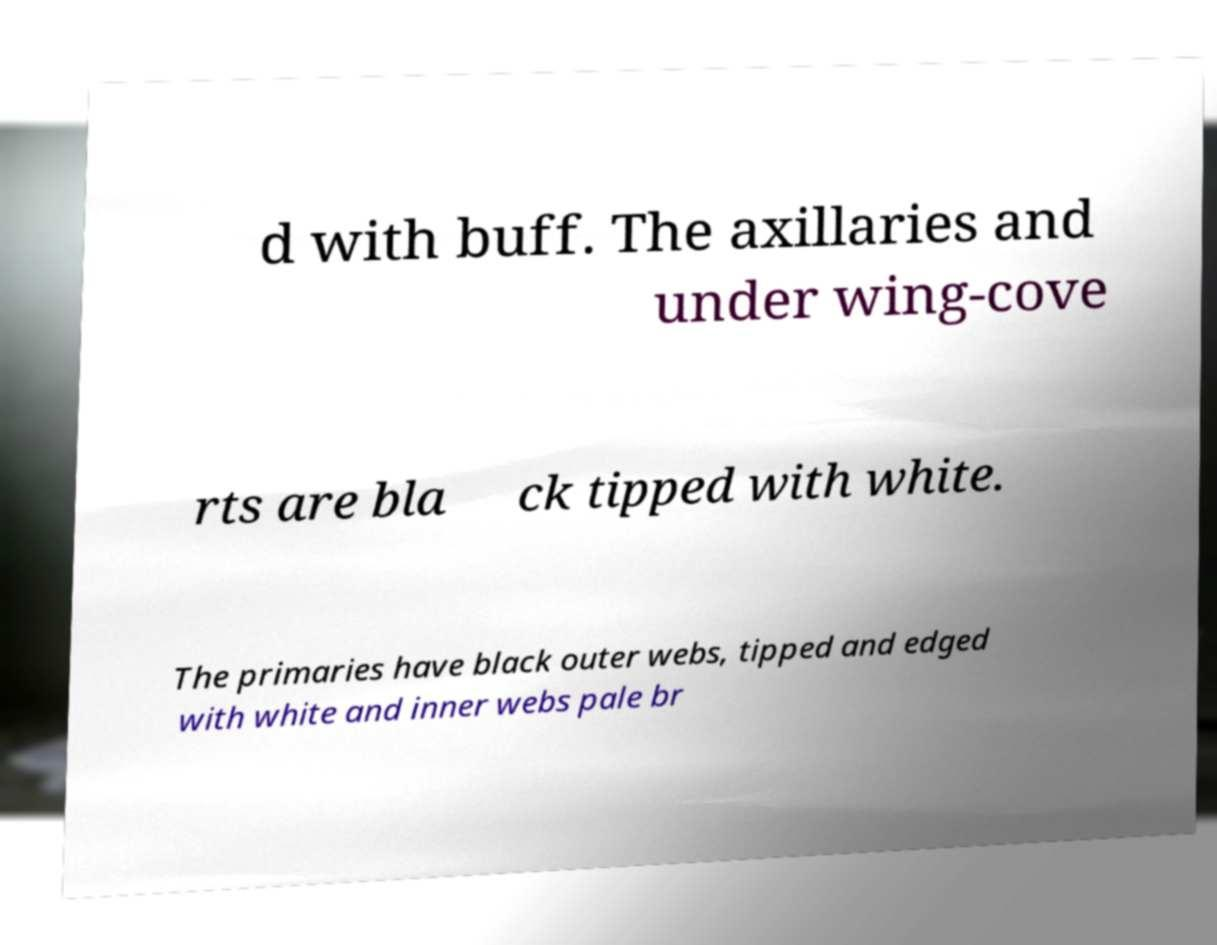I need the written content from this picture converted into text. Can you do that? d with buff. The axillaries and under wing-cove rts are bla ck tipped with white. The primaries have black outer webs, tipped and edged with white and inner webs pale br 